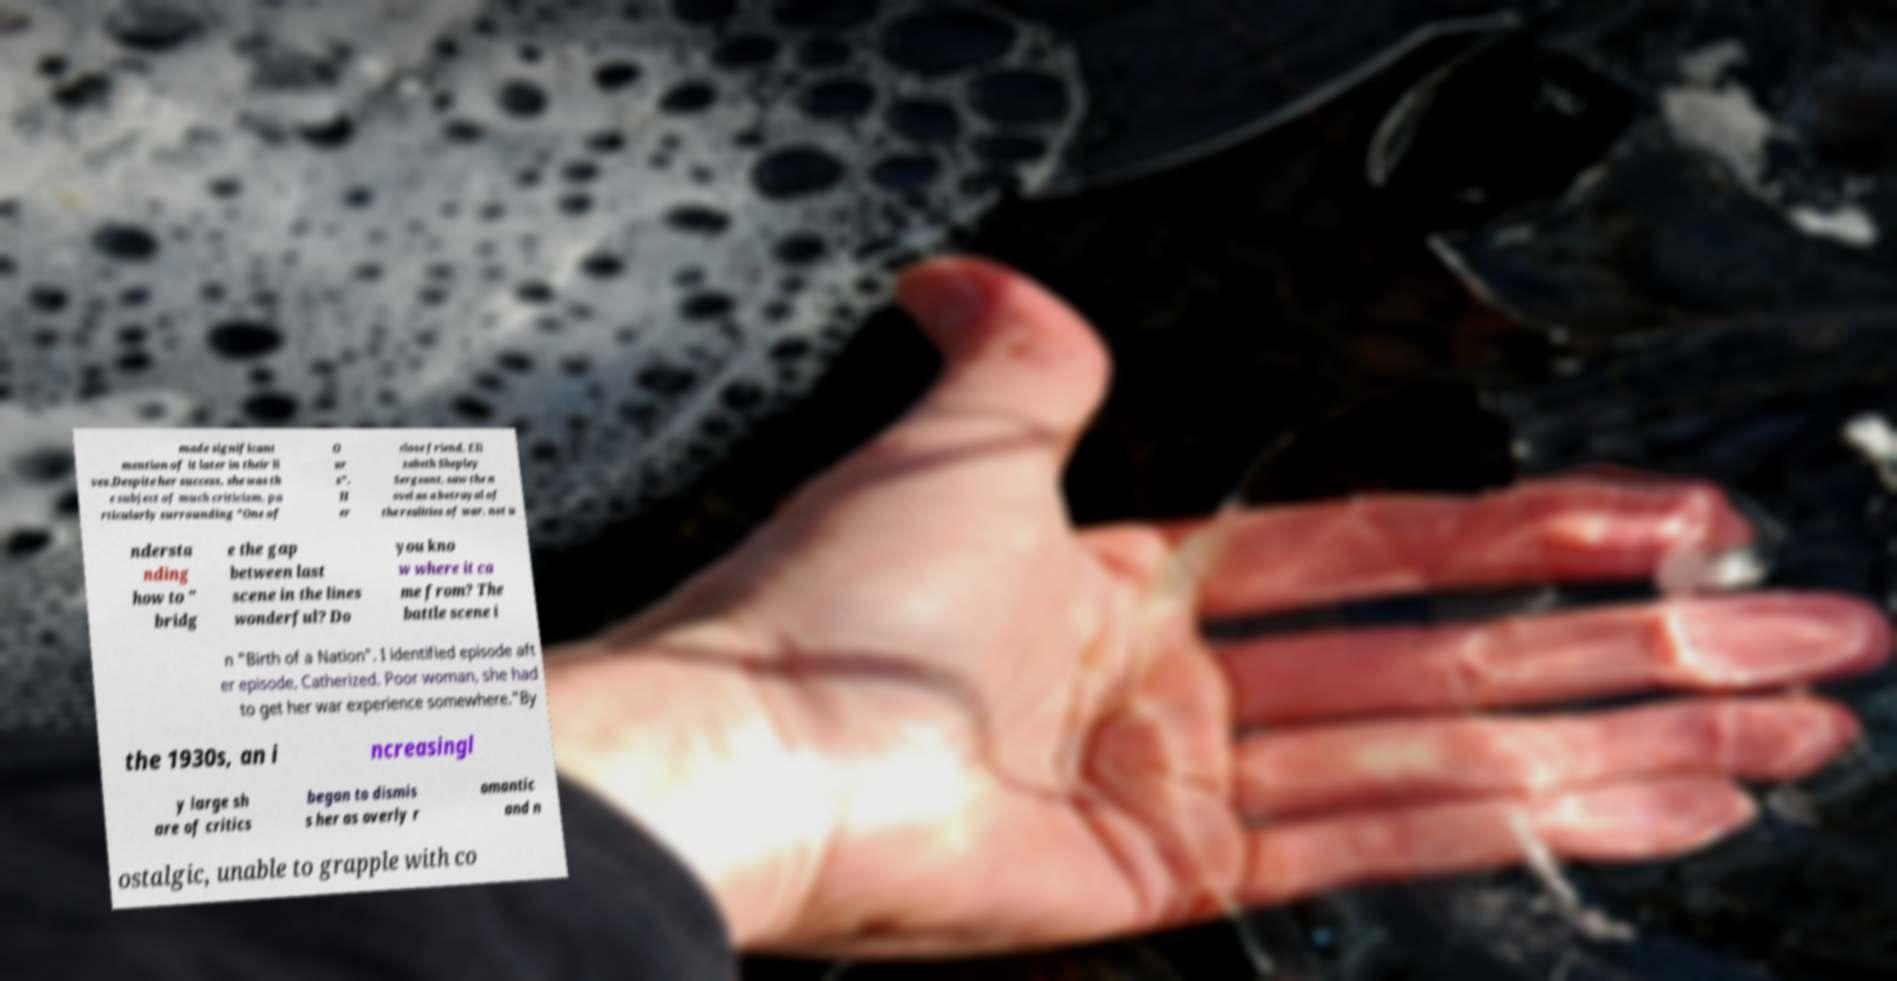Can you accurately transcribe the text from the provided image for me? made significant mention of it later in their li ves.Despite her success, she was th e subject of much criticism, pa rticularly surrounding "One of O ur s". H er close friend, Eli zabeth Shepley Sergeant, saw the n ovel as a betrayal of the realities of war, not u ndersta nding how to " bridg e the gap between last scene in the lines wonderful? Do you kno w where it ca me from? The battle scene i n "Birth of a Nation". I identified episode aft er episode, Catherized. Poor woman, she had to get her war experience somewhere."By the 1930s, an i ncreasingl y large sh are of critics began to dismis s her as overly r omantic and n ostalgic, unable to grapple with co 